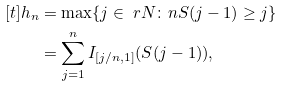<formula> <loc_0><loc_0><loc_500><loc_500>[ t ] h _ { n } & = \max \{ j \in { \ r N } \colon n S ( j - 1 ) \geq j \} \\ & = \sum _ { j = 1 } ^ { n } I _ { [ j / n , 1 ] } ( S ( j - 1 ) ) ,</formula> 